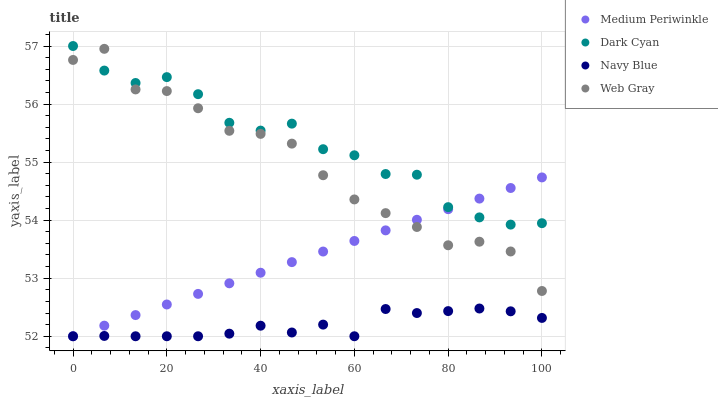Does Navy Blue have the minimum area under the curve?
Answer yes or no. Yes. Does Dark Cyan have the maximum area under the curve?
Answer yes or no. Yes. Does Web Gray have the minimum area under the curve?
Answer yes or no. No. Does Web Gray have the maximum area under the curve?
Answer yes or no. No. Is Medium Periwinkle the smoothest?
Answer yes or no. Yes. Is Dark Cyan the roughest?
Answer yes or no. Yes. Is Navy Blue the smoothest?
Answer yes or no. No. Is Navy Blue the roughest?
Answer yes or no. No. Does Navy Blue have the lowest value?
Answer yes or no. Yes. Does Web Gray have the lowest value?
Answer yes or no. No. Does Dark Cyan have the highest value?
Answer yes or no. Yes. Does Web Gray have the highest value?
Answer yes or no. No. Is Navy Blue less than Web Gray?
Answer yes or no. Yes. Is Web Gray greater than Navy Blue?
Answer yes or no. Yes. Does Medium Periwinkle intersect Web Gray?
Answer yes or no. Yes. Is Medium Periwinkle less than Web Gray?
Answer yes or no. No. Is Medium Periwinkle greater than Web Gray?
Answer yes or no. No. Does Navy Blue intersect Web Gray?
Answer yes or no. No. 